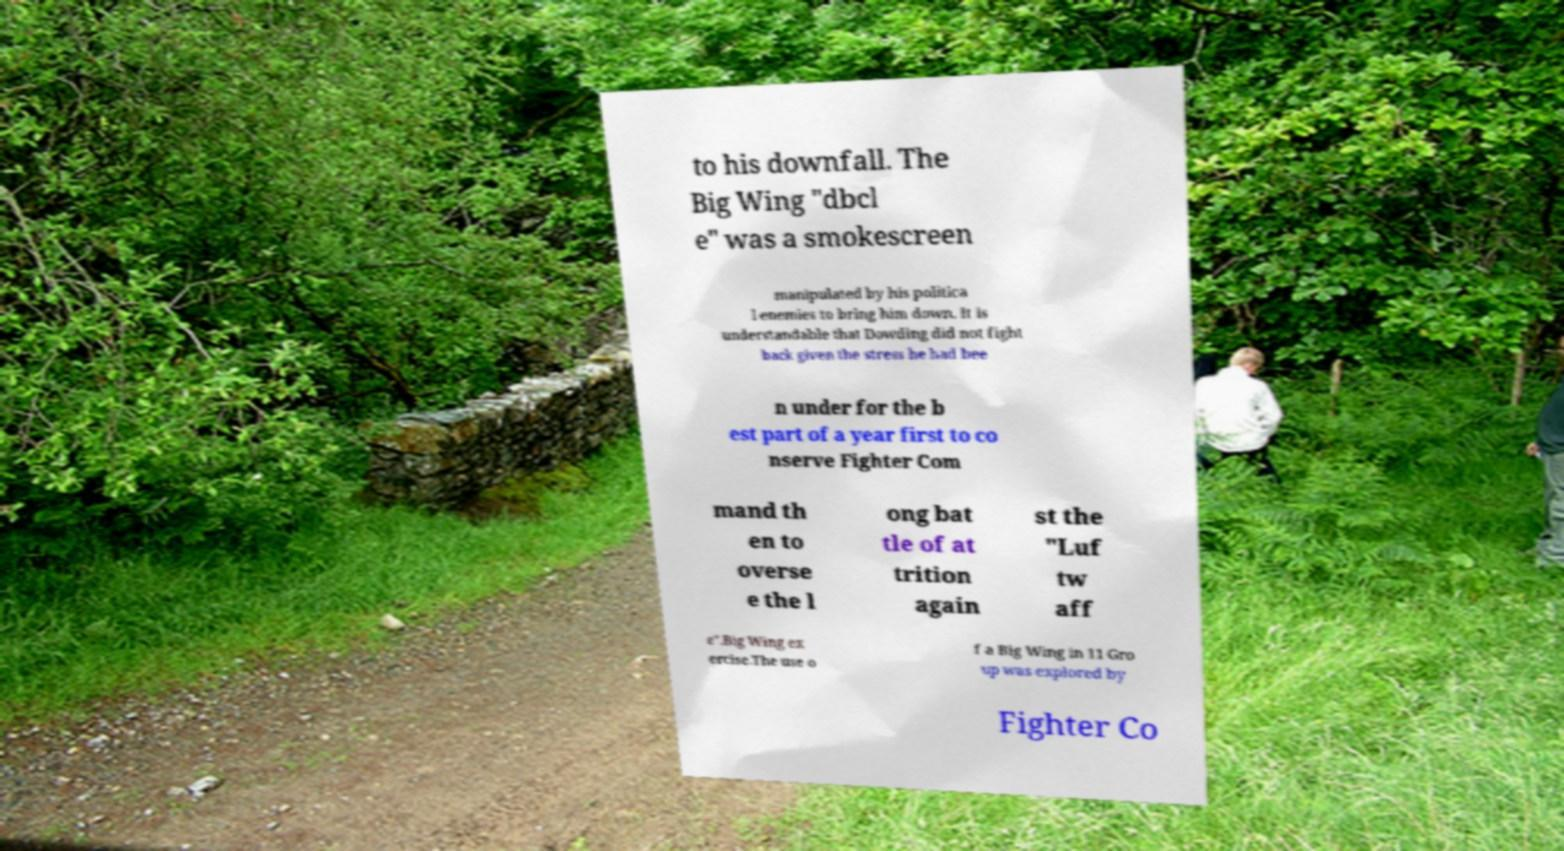Could you extract and type out the text from this image? to his downfall. The Big Wing "dbcl e" was a smokescreen manipulated by his politica l enemies to bring him down. It is understandable that Dowding did not fight back given the stress he had bee n under for the b est part of a year first to co nserve Fighter Com mand th en to overse e the l ong bat tle of at trition again st the "Luf tw aff e".Big Wing ex ercise.The use o f a Big Wing in 11 Gro up was explored by Fighter Co 